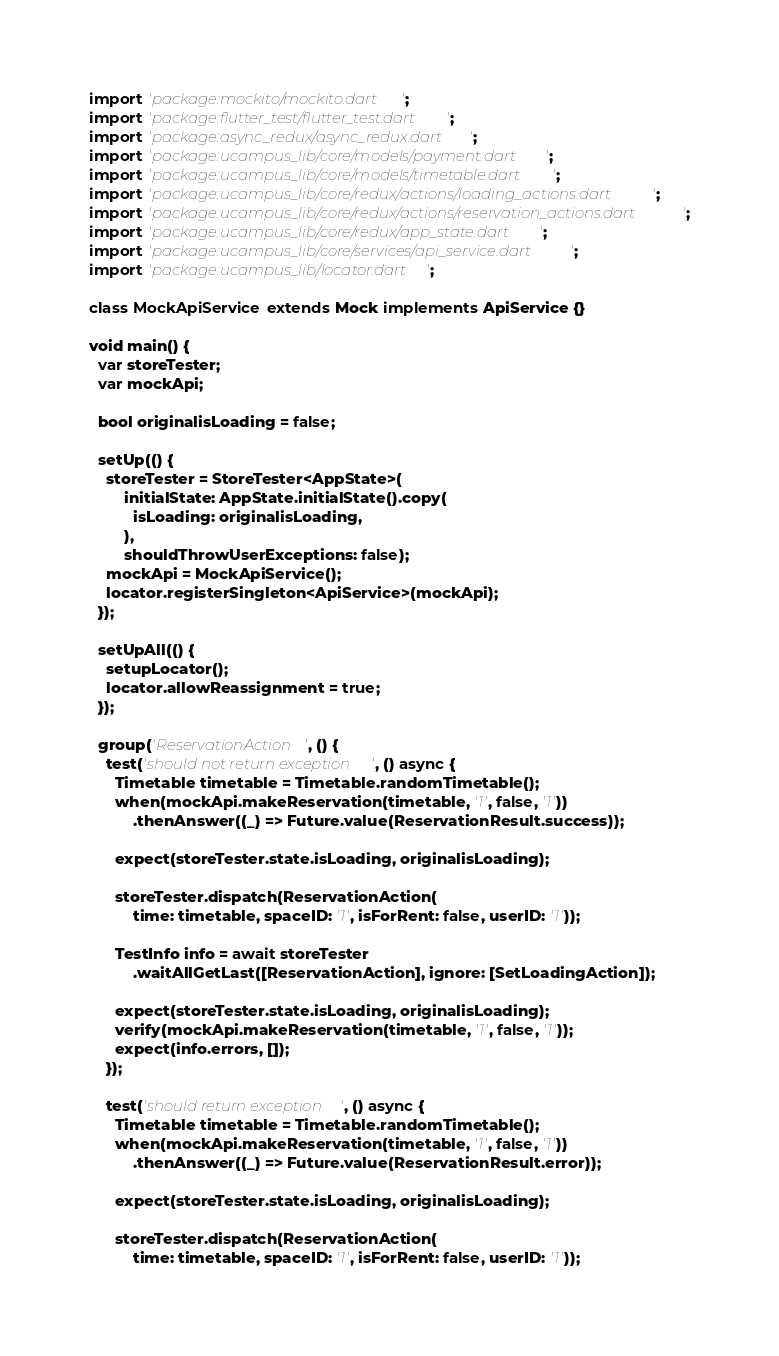<code> <loc_0><loc_0><loc_500><loc_500><_Dart_>import 'package:mockito/mockito.dart';
import 'package:flutter_test/flutter_test.dart';
import 'package:async_redux/async_redux.dart';
import 'package:ucampus_lib/core/models/payment.dart';
import 'package:ucampus_lib/core/models/timetable.dart';
import 'package:ucampus_lib/core/redux/actions/loading_actions.dart';
import 'package:ucampus_lib/core/redux/actions/reservation_actions.dart';
import 'package:ucampus_lib/core/redux/app_state.dart';
import 'package:ucampus_lib/core/services/api_service.dart';
import 'package:ucampus_lib/locator.dart';

class MockApiService extends Mock implements ApiService {}

void main() {
  var storeTester;
  var mockApi;

  bool originalisLoading = false;

  setUp(() {
    storeTester = StoreTester<AppState>(
        initialState: AppState.initialState().copy(
          isLoading: originalisLoading,
        ),
        shouldThrowUserExceptions: false);
    mockApi = MockApiService();
    locator.registerSingleton<ApiService>(mockApi);
  });

  setUpAll(() {
    setupLocator();
    locator.allowReassignment = true;
  });

  group('ReservationAction', () {
    test('should not return exception', () async {
      Timetable timetable = Timetable.randomTimetable();
      when(mockApi.makeReservation(timetable, '1', false, '1'))
          .thenAnswer((_) => Future.value(ReservationResult.success));

      expect(storeTester.state.isLoading, originalisLoading);

      storeTester.dispatch(ReservationAction(
          time: timetable, spaceID: '1', isForRent: false, userID: '1'));

      TestInfo info = await storeTester
          .waitAllGetLast([ReservationAction], ignore: [SetLoadingAction]);

      expect(storeTester.state.isLoading, originalisLoading);
      verify(mockApi.makeReservation(timetable, '1', false, '1'));
      expect(info.errors, []);
    });

    test('should return exception', () async {
      Timetable timetable = Timetable.randomTimetable();
      when(mockApi.makeReservation(timetable, '1', false, '1'))
          .thenAnswer((_) => Future.value(ReservationResult.error));

      expect(storeTester.state.isLoading, originalisLoading);

      storeTester.dispatch(ReservationAction(
          time: timetable, spaceID: '1', isForRent: false, userID: '1'));</code> 